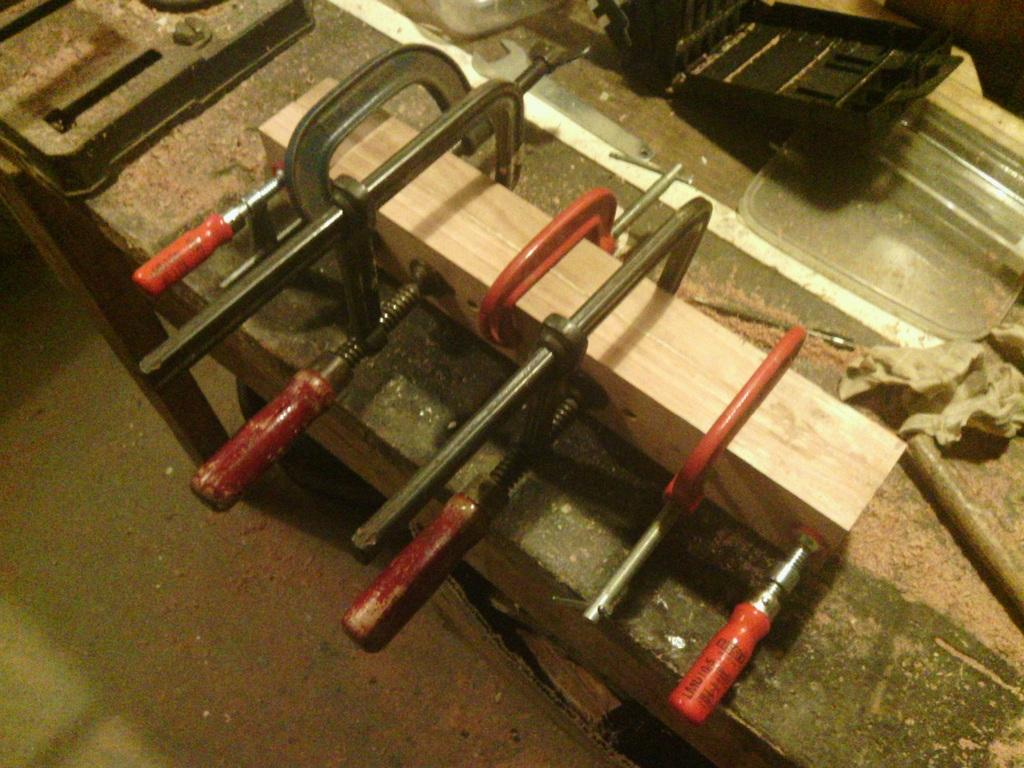What objects can be seen on the table in the image? There are tools on a table in the image. What might be a byproduct of using the tools in the image? Sawdust is visible in the image, which might be a byproduct of using the tools. What type of insurance is required for the tools in the image? There is no information about insurance in the image, so it cannot be determined from the image. 